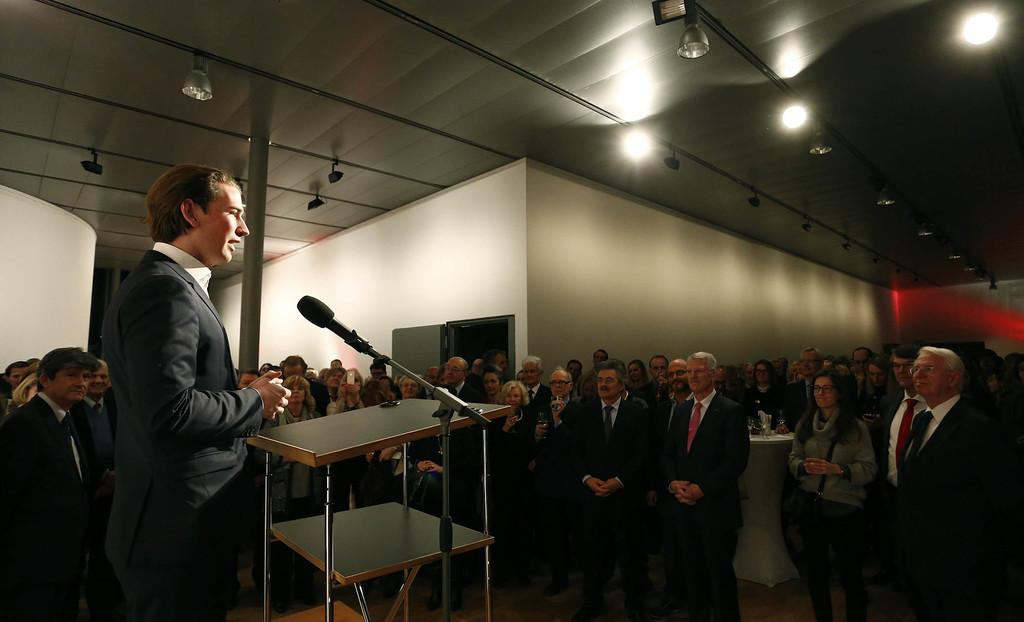What type of venue is shown in the image? The image depicts a conference hall. How are the people in the image positioned? There are many people standing on the floor in the image. What are the people in the image doing? The people are listening to a person at the podium. What is the person at the podium using to amplify their voice? The person at the podium is speaking on a microphone. What can be seen on the rooftop of the conference hall? There are lights visible on the rooftop. What type of cork can be seen being twisted by the person at the podium? There is no cork or twisting action present in the image; the person at the podium is speaking on a microphone. 